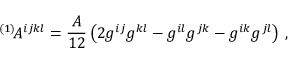Convert formula to latex. <formula><loc_0><loc_0><loc_500><loc_500>{ } ^ { ( 1 ) } \, A ^ { i j k l } = \frac { A } { 1 2 } \left ( 2 g ^ { i j } g ^ { k l } - g ^ { i l } g ^ { j k } - g ^ { i k } g ^ { j l } \right ) \, ,</formula> 